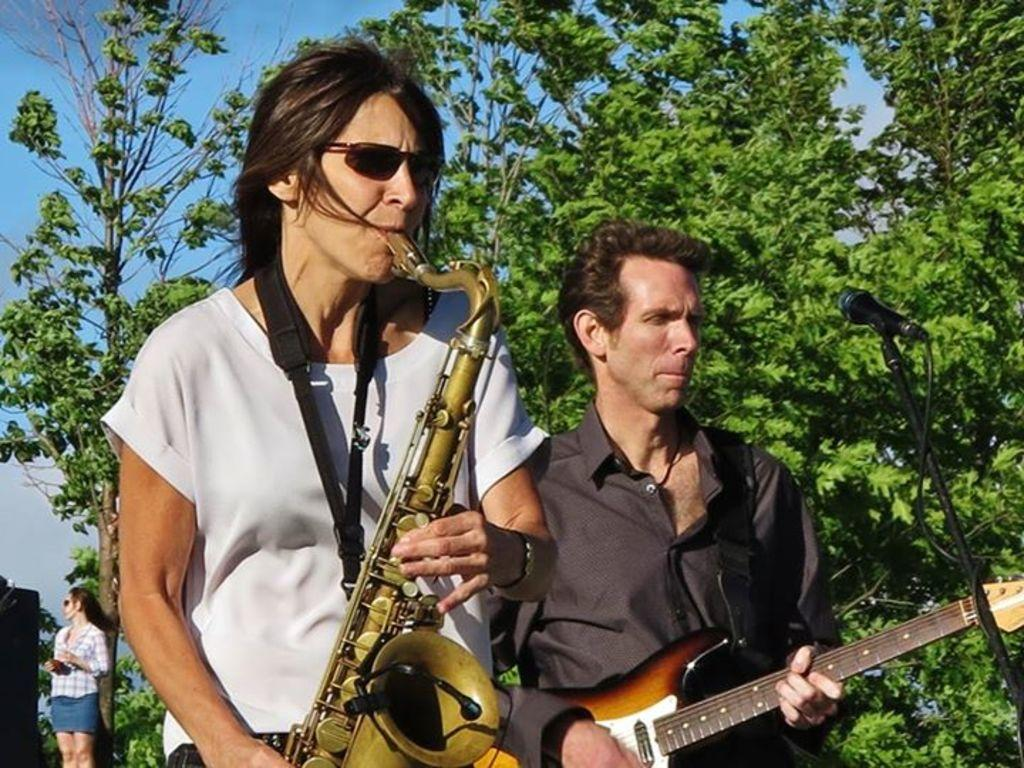How many people are in the image? There are two persons in the image. What are the persons doing in the image? The persons are standing and playing musical instruments. Can you describe the background of the image? There is a tree in the image, and a woman is standing far away. What equipment is visible in front of one of the persons? There is a mic with a mic holder in front of one of the persons. What is the color of the sky in the image? The sky is blue in color. How many geese are flying over the persons in the image? There are no geese visible in the image; it only features two persons playing musical instruments, a tree, a woman standing far away, a mic, and a mic holder. 